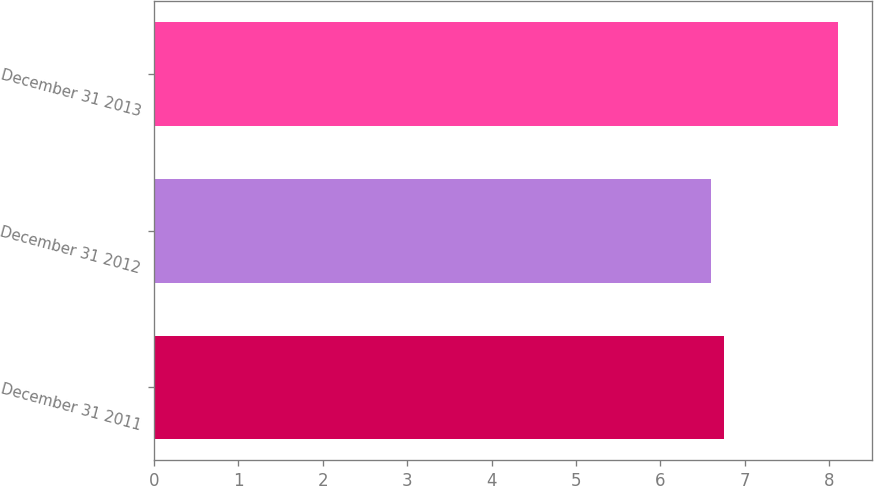<chart> <loc_0><loc_0><loc_500><loc_500><bar_chart><fcel>December 31 2011<fcel>December 31 2012<fcel>December 31 2013<nl><fcel>6.75<fcel>6.6<fcel>8.1<nl></chart> 